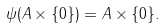<formula> <loc_0><loc_0><loc_500><loc_500>\psi ( A \times \{ 0 \} ) = A \times \{ 0 \} .</formula> 